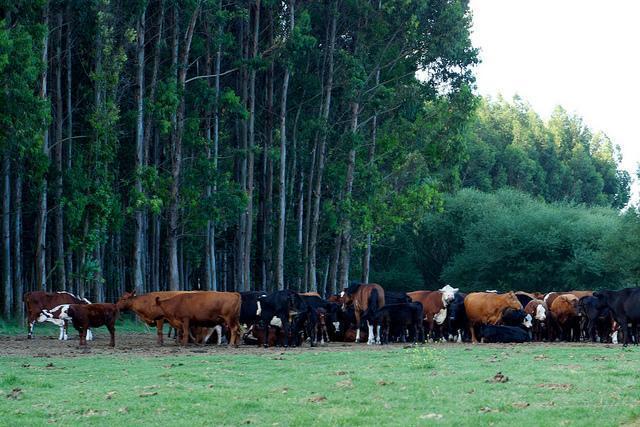How many cows are there?
Give a very brief answer. 2. How many boys are playing?
Give a very brief answer. 0. 